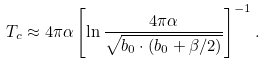Convert formula to latex. <formula><loc_0><loc_0><loc_500><loc_500>T _ { c } \approx 4 \pi \alpha \left [ \ln \frac { 4 \pi \alpha } { \sqrt { b _ { 0 } \cdot ( b _ { 0 } + \beta / 2 ) } } \right ] ^ { - 1 } .</formula> 